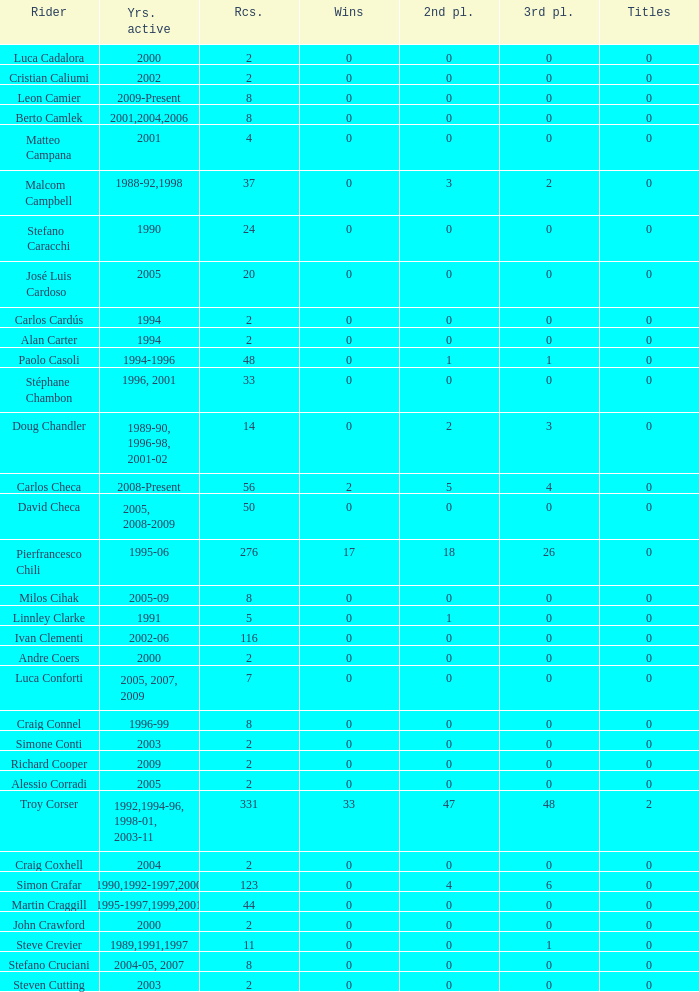What is the total number of wins for riders with fewer than 56 races and more than 0 titles? 0.0. 